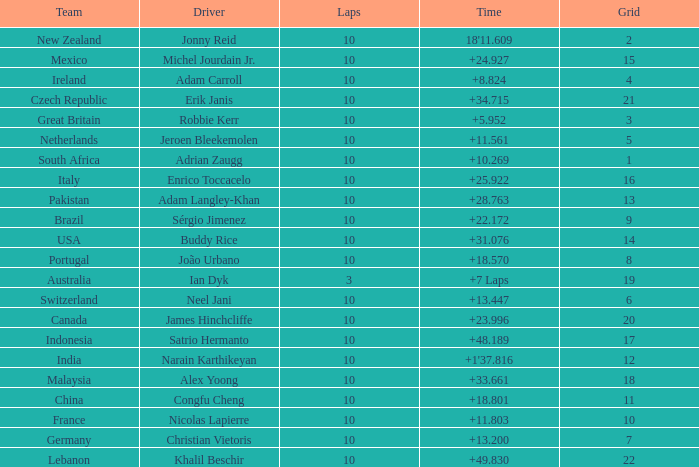What is the Grid number for the Team from Italy? 1.0. Can you give me this table as a dict? {'header': ['Team', 'Driver', 'Laps', 'Time', 'Grid'], 'rows': [['New Zealand', 'Jonny Reid', '10', "18'11.609", '2'], ['Mexico', 'Michel Jourdain Jr.', '10', '+24.927', '15'], ['Ireland', 'Adam Carroll', '10', '+8.824', '4'], ['Czech Republic', 'Erik Janis', '10', '+34.715', '21'], ['Great Britain', 'Robbie Kerr', '10', '+5.952', '3'], ['Netherlands', 'Jeroen Bleekemolen', '10', '+11.561', '5'], ['South Africa', 'Adrian Zaugg', '10', '+10.269', '1'], ['Italy', 'Enrico Toccacelo', '10', '+25.922', '16'], ['Pakistan', 'Adam Langley-Khan', '10', '+28.763', '13'], ['Brazil', 'Sérgio Jimenez', '10', '+22.172', '9'], ['USA', 'Buddy Rice', '10', '+31.076', '14'], ['Portugal', 'João Urbano', '10', '+18.570', '8'], ['Australia', 'Ian Dyk', '3', '+7 Laps', '19'], ['Switzerland', 'Neel Jani', '10', '+13.447', '6'], ['Canada', 'James Hinchcliffe', '10', '+23.996', '20'], ['Indonesia', 'Satrio Hermanto', '10', '+48.189', '17'], ['India', 'Narain Karthikeyan', '10', "+1'37.816", '12'], ['Malaysia', 'Alex Yoong', '10', '+33.661', '18'], ['China', 'Congfu Cheng', '10', '+18.801', '11'], ['France', 'Nicolas Lapierre', '10', '+11.803', '10'], ['Germany', 'Christian Vietoris', '10', '+13.200', '7'], ['Lebanon', 'Khalil Beschir', '10', '+49.830', '22']]} 